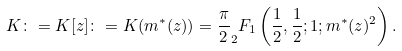Convert formula to latex. <formula><loc_0><loc_0><loc_500><loc_500>K \colon = K [ z ] \colon = K ( m ^ { * } ( z ) ) = \frac { \pi } { 2 } _ { 2 } F _ { 1 } \left ( \frac { 1 } { 2 } , \frac { 1 } { 2 } ; 1 ; m ^ { * } ( z ) ^ { 2 } \right ) .</formula> 